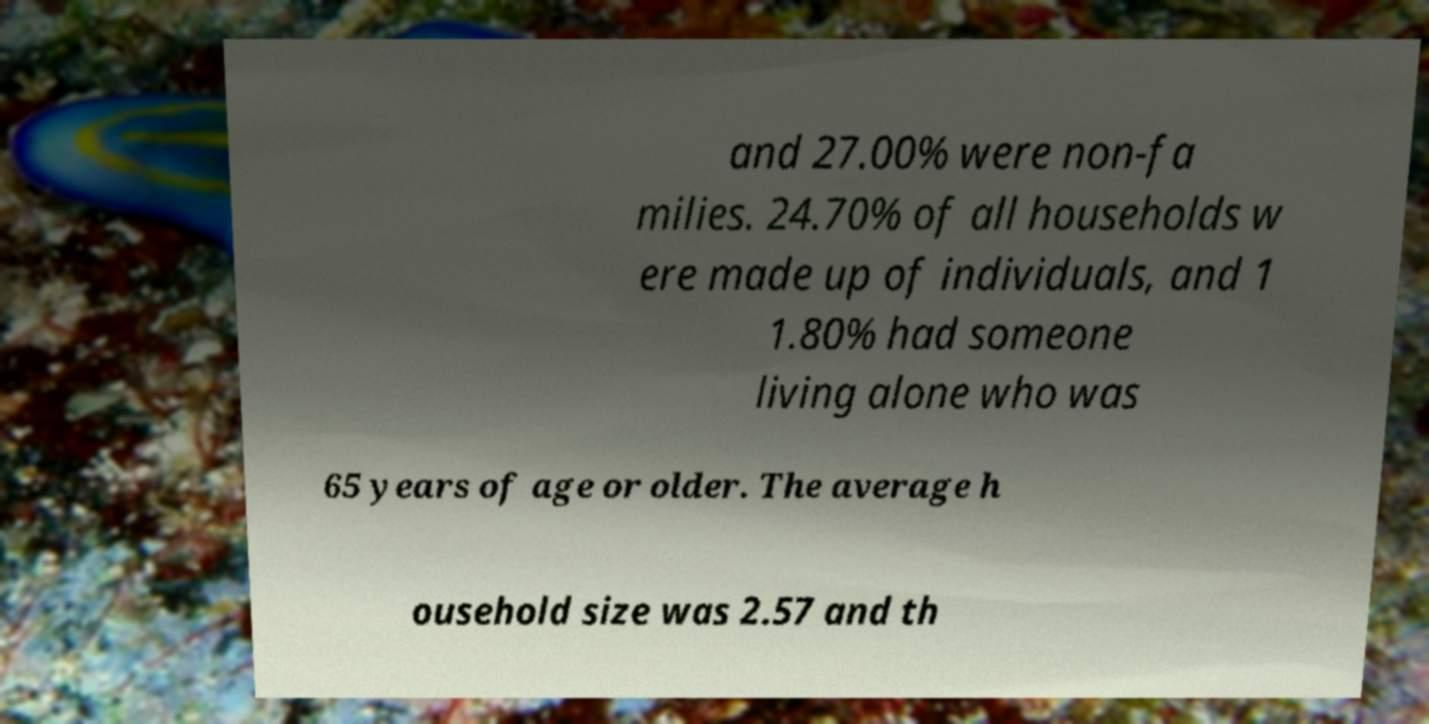Can you accurately transcribe the text from the provided image for me? and 27.00% were non-fa milies. 24.70% of all households w ere made up of individuals, and 1 1.80% had someone living alone who was 65 years of age or older. The average h ousehold size was 2.57 and th 